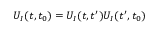Convert formula to latex. <formula><loc_0><loc_0><loc_500><loc_500>U _ { I } ( t , t _ { 0 } ) = U _ { I } ( t , t ^ { \prime } ) U _ { I } ( t ^ { \prime } , t _ { 0 } )</formula> 